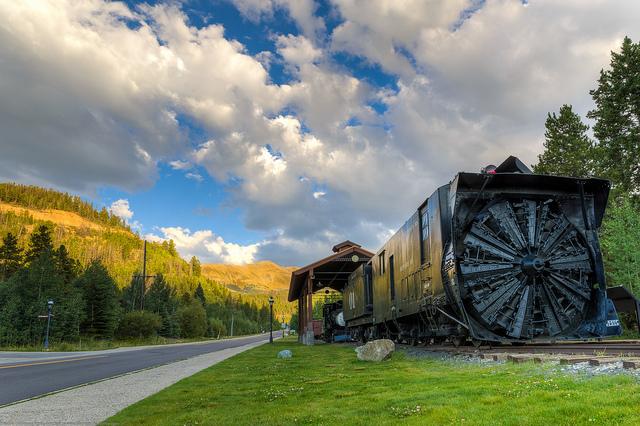What mode of transport is shown?
Concise answer only. Train. What are the weather conditions?
Give a very brief answer. Cloudy. Why are there clouds?
Short answer required. Cloudy. 